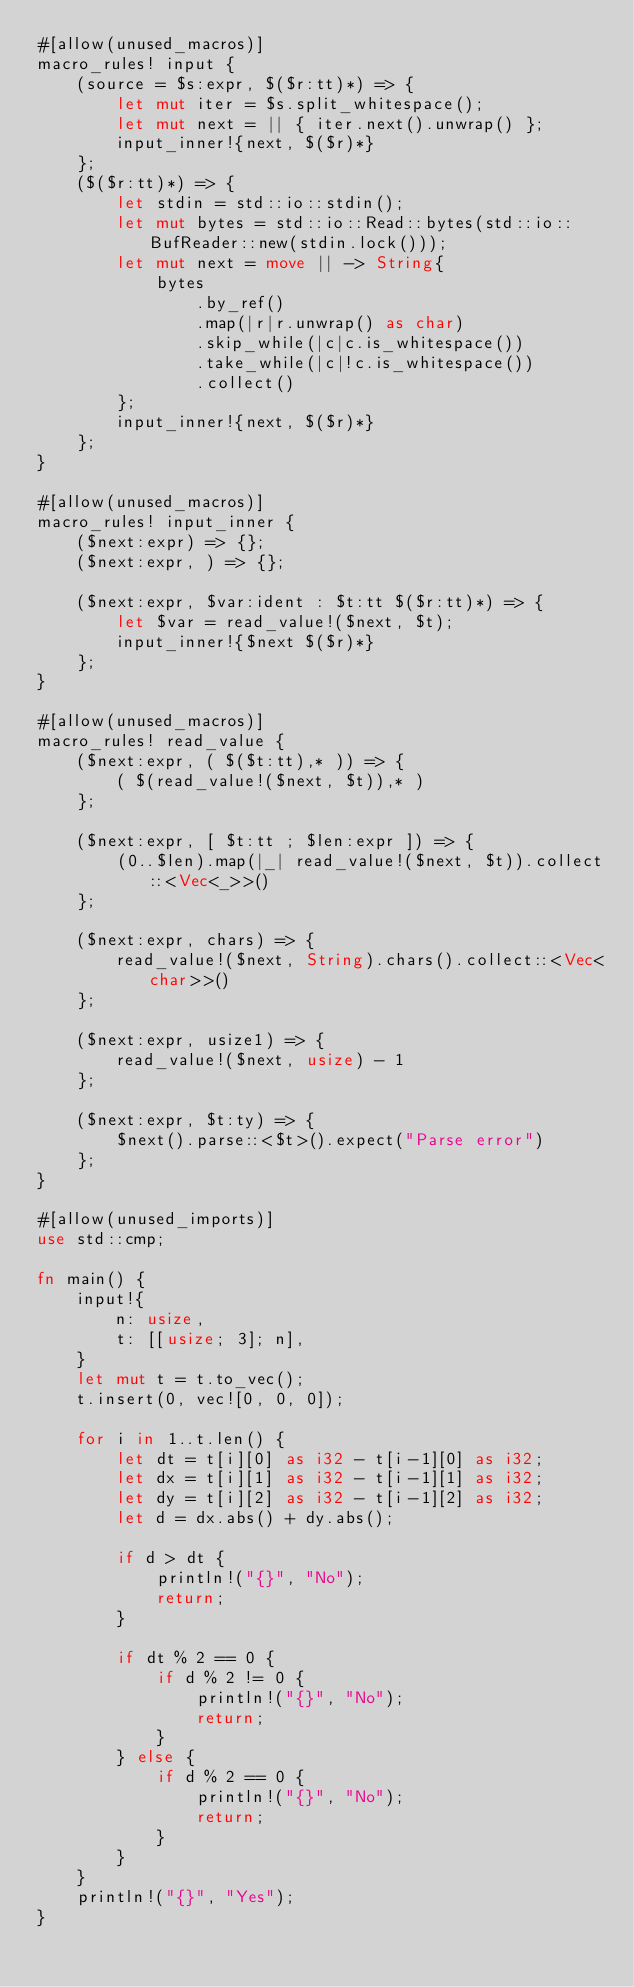Convert code to text. <code><loc_0><loc_0><loc_500><loc_500><_Rust_>#[allow(unused_macros)]
macro_rules! input {
    (source = $s:expr, $($r:tt)*) => {
        let mut iter = $s.split_whitespace();
        let mut next = || { iter.next().unwrap() };
        input_inner!{next, $($r)*}
    };
    ($($r:tt)*) => {
        let stdin = std::io::stdin();
        let mut bytes = std::io::Read::bytes(std::io::BufReader::new(stdin.lock()));
        let mut next = move || -> String{
            bytes
                .by_ref()
                .map(|r|r.unwrap() as char)
                .skip_while(|c|c.is_whitespace())
                .take_while(|c|!c.is_whitespace())
                .collect()
        };
        input_inner!{next, $($r)*}
    };
}

#[allow(unused_macros)]
macro_rules! input_inner {
    ($next:expr) => {};
    ($next:expr, ) => {};

    ($next:expr, $var:ident : $t:tt $($r:tt)*) => {
        let $var = read_value!($next, $t);
        input_inner!{$next $($r)*}
    };
}

#[allow(unused_macros)]
macro_rules! read_value {
    ($next:expr, ( $($t:tt),* )) => {
        ( $(read_value!($next, $t)),* )
    };

    ($next:expr, [ $t:tt ; $len:expr ]) => {
        (0..$len).map(|_| read_value!($next, $t)).collect::<Vec<_>>()
    };

    ($next:expr, chars) => {
        read_value!($next, String).chars().collect::<Vec<char>>()
    };

    ($next:expr, usize1) => {
        read_value!($next, usize) - 1
    };

    ($next:expr, $t:ty) => {
        $next().parse::<$t>().expect("Parse error")
    };
}

#[allow(unused_imports)]
use std::cmp;

fn main() {
    input!{
        n: usize,
        t: [[usize; 3]; n],
    }
    let mut t = t.to_vec();
    t.insert(0, vec![0, 0, 0]);

    for i in 1..t.len() {
        let dt = t[i][0] as i32 - t[i-1][0] as i32;
        let dx = t[i][1] as i32 - t[i-1][1] as i32;
        let dy = t[i][2] as i32 - t[i-1][2] as i32;
        let d = dx.abs() + dy.abs();

        if d > dt {
            println!("{}", "No");
            return;
        }

        if dt % 2 == 0 {
            if d % 2 != 0 {
                println!("{}", "No");
                return;
            }
        } else {
            if d % 2 == 0 {
                println!("{}", "No");
                return;
            }
        }
    }
    println!("{}", "Yes");
}
</code> 